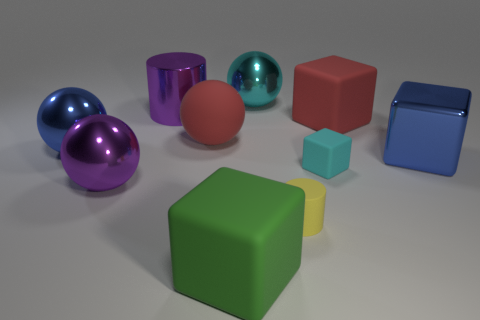There is a rubber block that is in front of the tiny cylinder; how many big rubber things are behind it?
Your response must be concise. 2. Are there any tiny yellow matte cylinders to the right of the cyan matte thing?
Make the answer very short. No. There is a large red rubber thing to the right of the tiny cyan block that is in front of the big cyan shiny sphere; what shape is it?
Your response must be concise. Cube. Are there fewer cyan rubber things that are right of the purple cylinder than blue metallic objects right of the cyan sphere?
Offer a terse response. No. There is a big metallic thing that is the same shape as the green rubber thing; what is its color?
Provide a succinct answer. Blue. What number of big metallic balls are both in front of the small cyan object and right of the large purple metal sphere?
Offer a terse response. 0. Is the number of tiny cyan matte blocks that are to the left of the large purple metallic ball greater than the number of small yellow matte cylinders behind the big cyan sphere?
Your answer should be very brief. No. What size is the green matte cube?
Offer a very short reply. Large. Is there a green rubber object that has the same shape as the small yellow matte thing?
Give a very brief answer. No. Do the cyan matte thing and the blue object that is to the left of the yellow rubber object have the same shape?
Provide a short and direct response. No. 